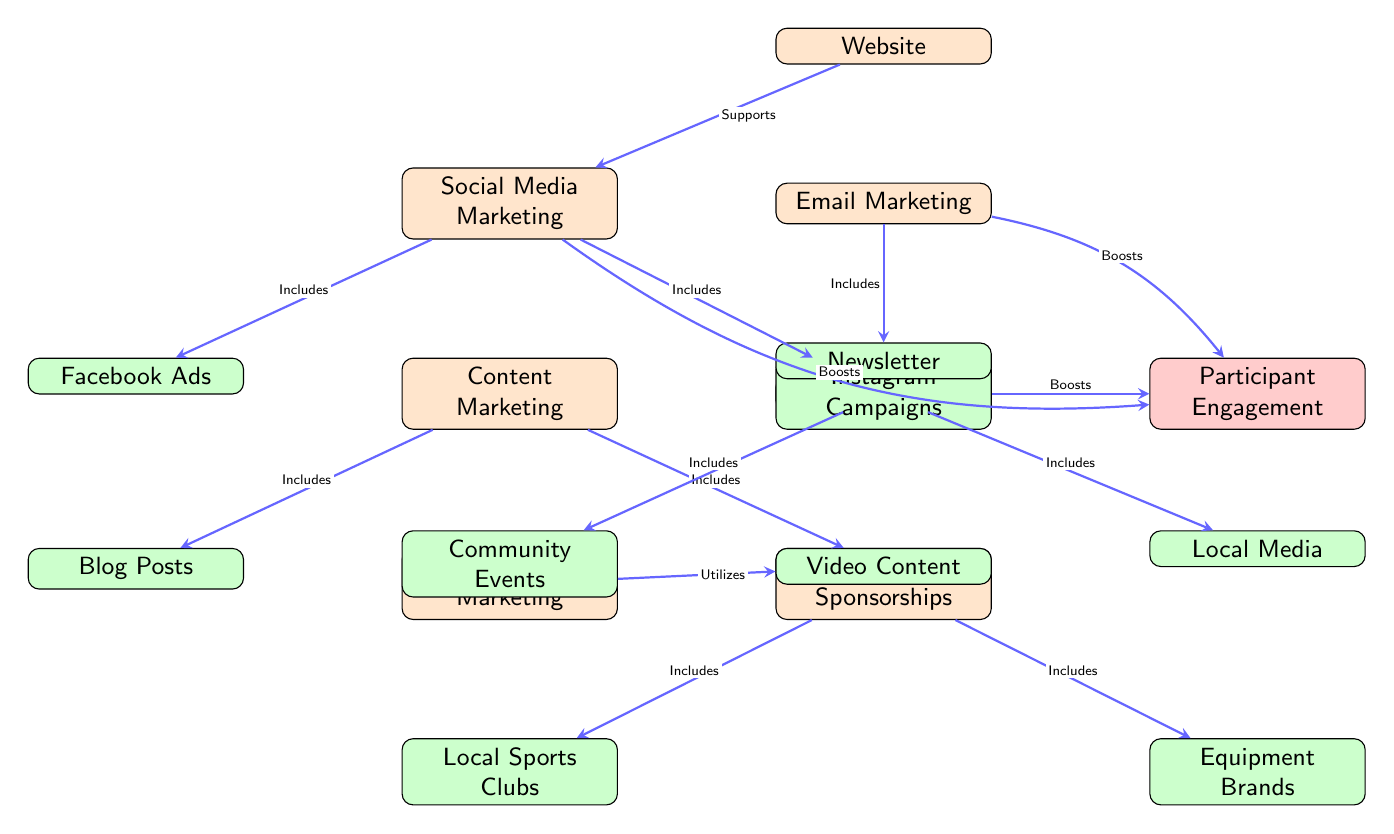What are the main marketing channels for promoting a tennis academy? The diagram lists four main marketing channels positioned vertically on the left side: Social Media Marketing, Content Marketing, Influencer Marketing, and Email Marketing.
Answer: Social Media Marketing, Content Marketing, Influencer Marketing, Email Marketing How many types of local promotions are included? The diagram shows two types of local promotions listed under Local Promotion: Community Events and Local Media.
Answer: 2 Which marketing channel includes video content? The Content Marketing node includes Video Content as a sub-node, and the Influencer Marketing node utilizes Video Content as well.
Answer: Content Marketing, Influencer Marketing What relationship does the Social Media Marketing node have with the website? The arrow indicates that the website supports Social Media Marketing. This means that having a website enhances or aids social media efforts.
Answer: Supports Which marketing strategy boosts participant engagement? The arrows from Email Marketing, Social Media Marketing, and Local Promotion all point towards Participant Engagement, indicating these strategies enhance engagement levels among participants.
Answer: Email Marketing, Social Media Marketing, Local Promotion How do influencer marketing efforts utilize video content? The Influencer Marketing node connects to the Video Content node, indicating that the influencer strategy incorporates video as one of its components.
Answer: Utilizes What is the final marketing channel that directly links to Participant Engagement? The diagram shows Local Promotion as one of the marketing strategies that boosts Participant Engagement, represented by an arrow connecting the two nodes.
Answer: Local Promotion What types of partnerships are involved in the promotional strategies? The Partnerships and Sponsorships node includes two specific types: Local Sports Clubs and Equipment Brands, indicating that promotional efforts involve collaborations with these organizations.
Answer: Local Sports Clubs, Equipment Brands 